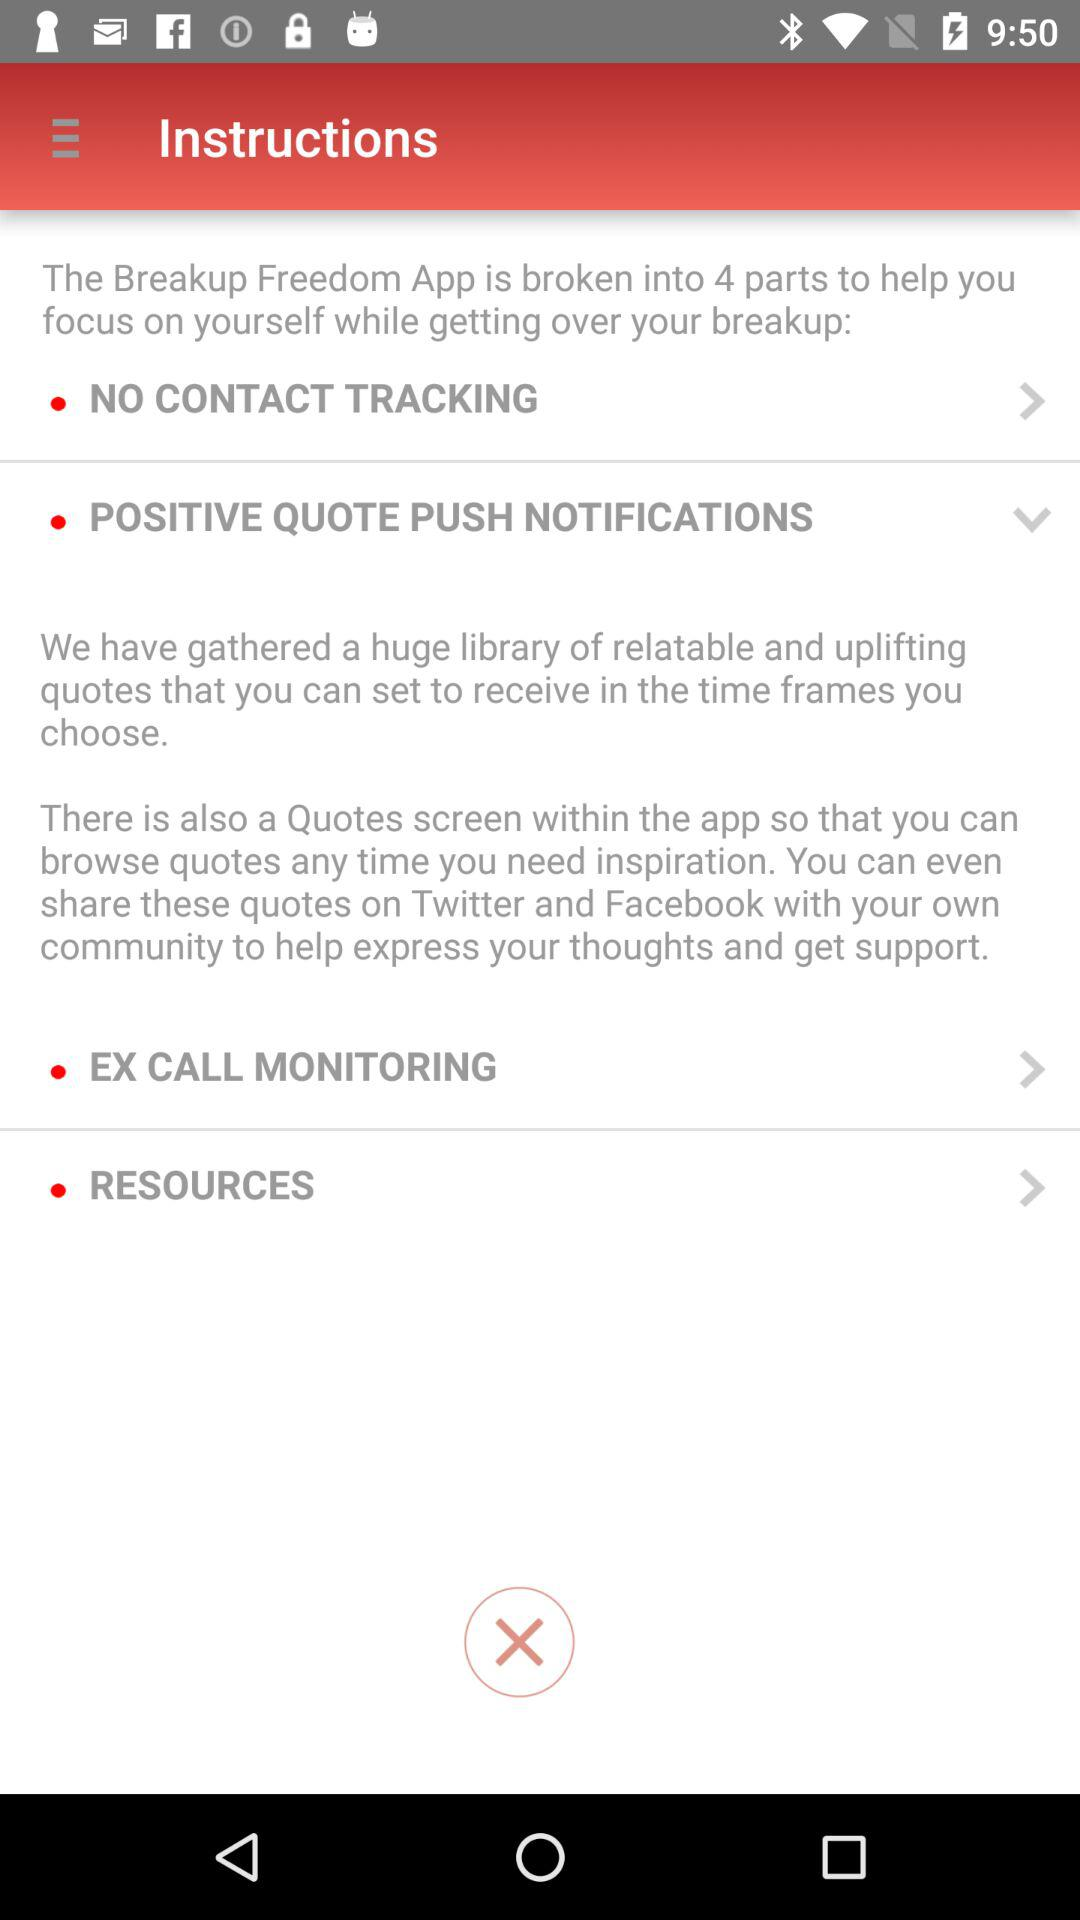How many time frames can you choose?
When the provided information is insufficient, respond with <no answer>. <no answer> 